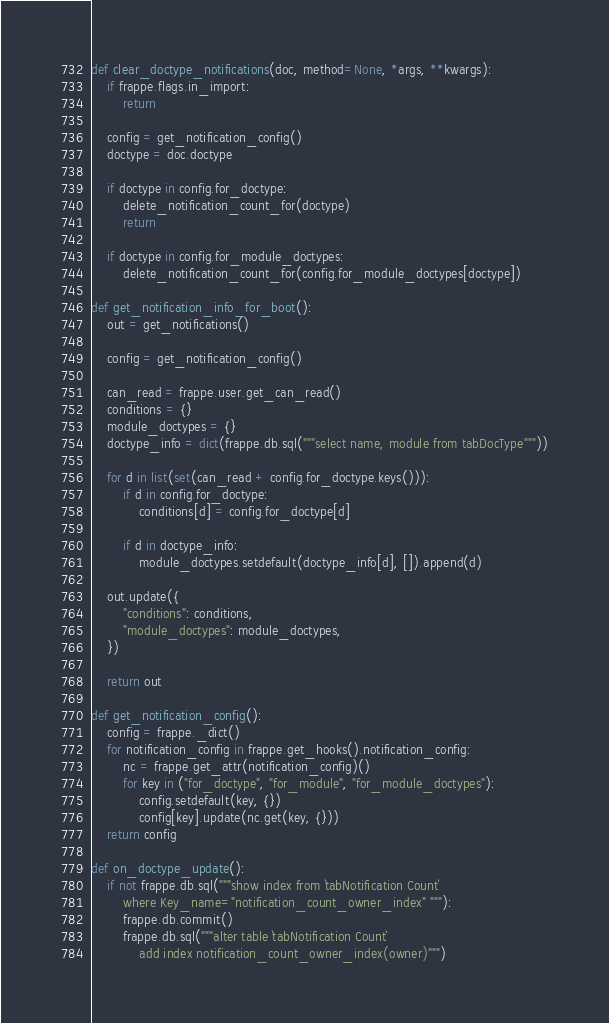Convert code to text. <code><loc_0><loc_0><loc_500><loc_500><_Python_>
def clear_doctype_notifications(doc, method=None, *args, **kwargs):
	if frappe.flags.in_import:
		return

	config = get_notification_config()
	doctype = doc.doctype

	if doctype in config.for_doctype:
		delete_notification_count_for(doctype)
		return

	if doctype in config.for_module_doctypes:
		delete_notification_count_for(config.for_module_doctypes[doctype])

def get_notification_info_for_boot():
	out = get_notifications()

	config = get_notification_config()

	can_read = frappe.user.get_can_read()
	conditions = {}
	module_doctypes = {}
	doctype_info = dict(frappe.db.sql("""select name, module from tabDocType"""))

	for d in list(set(can_read + config.for_doctype.keys())):
		if d in config.for_doctype:
			conditions[d] = config.for_doctype[d]

		if d in doctype_info:
			module_doctypes.setdefault(doctype_info[d], []).append(d)

	out.update({
		"conditions": conditions,
		"module_doctypes": module_doctypes,
	})

	return out

def get_notification_config():
	config = frappe._dict()
	for notification_config in frappe.get_hooks().notification_config:
		nc = frappe.get_attr(notification_config)()
		for key in ("for_doctype", "for_module", "for_module_doctypes"):
			config.setdefault(key, {})
			config[key].update(nc.get(key, {}))
	return config

def on_doctype_update():
	if not frappe.db.sql("""show index from `tabNotification Count`
		where Key_name="notification_count_owner_index" """):
		frappe.db.commit()
		frappe.db.sql("""alter table `tabNotification Count`
			add index notification_count_owner_index(owner)""")

</code> 